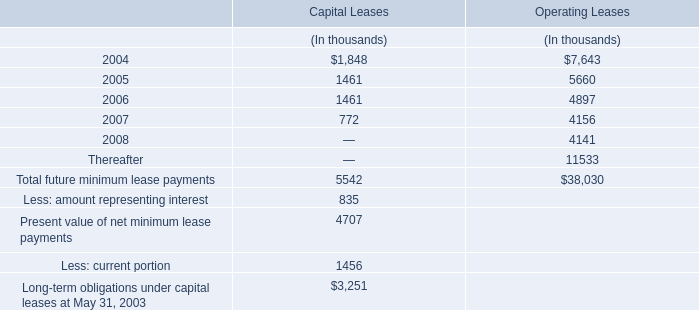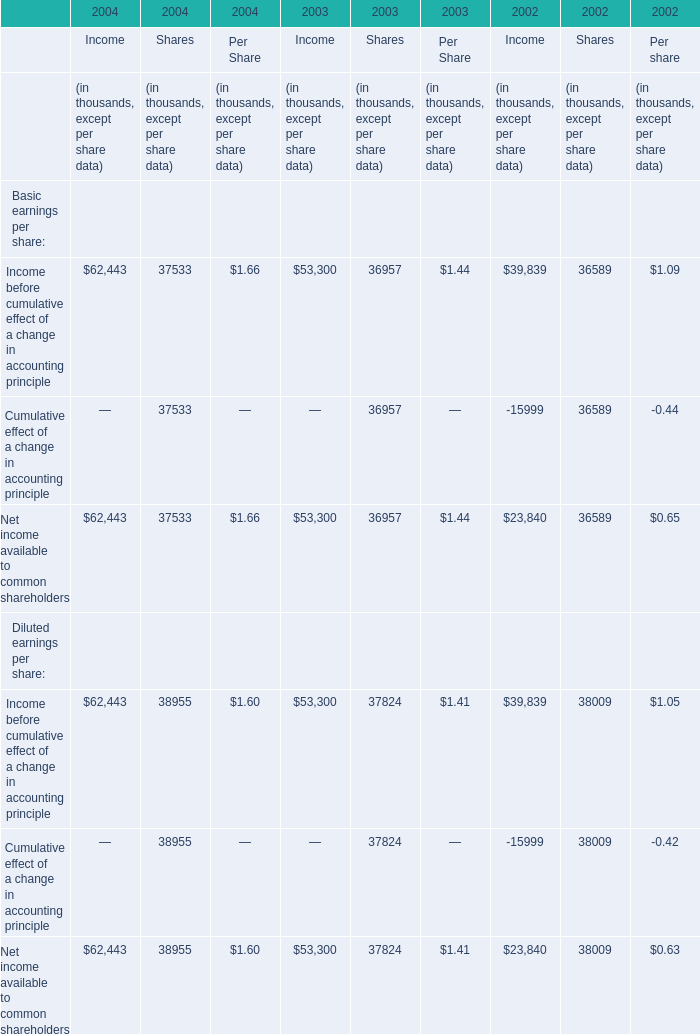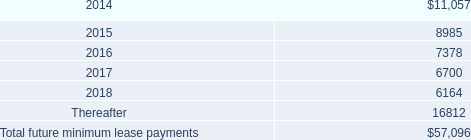what percentage of lease payments will be paid out in the first year? 
Computations: (11057 / 57096)
Answer: 0.19366. 